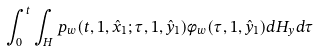<formula> <loc_0><loc_0><loc_500><loc_500>\int _ { 0 } ^ { t } \int _ { H } p _ { w } ( t , 1 , \hat { x } _ { 1 } ; \tau , 1 , \hat { y } _ { 1 } ) \phi _ { w } ( \tau , 1 , \hat { y } _ { 1 } ) d H _ { y } d \tau</formula> 